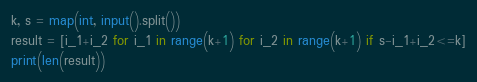<code> <loc_0><loc_0><loc_500><loc_500><_Python_>k, s = map(int, input().split())
result = [i_1+i_2 for i_1 in range(k+1) for i_2 in range(k+1) if s-i_1+i_2<=k]
print(len(result))</code> 